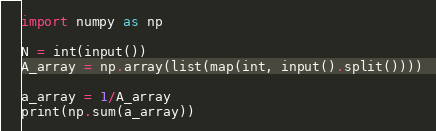<code> <loc_0><loc_0><loc_500><loc_500><_Python_>import numpy as np

N = int(input())
A_array = np.array(list(map(int, input().split())))

a_array = 1/A_array
print(np.sum(a_array))</code> 